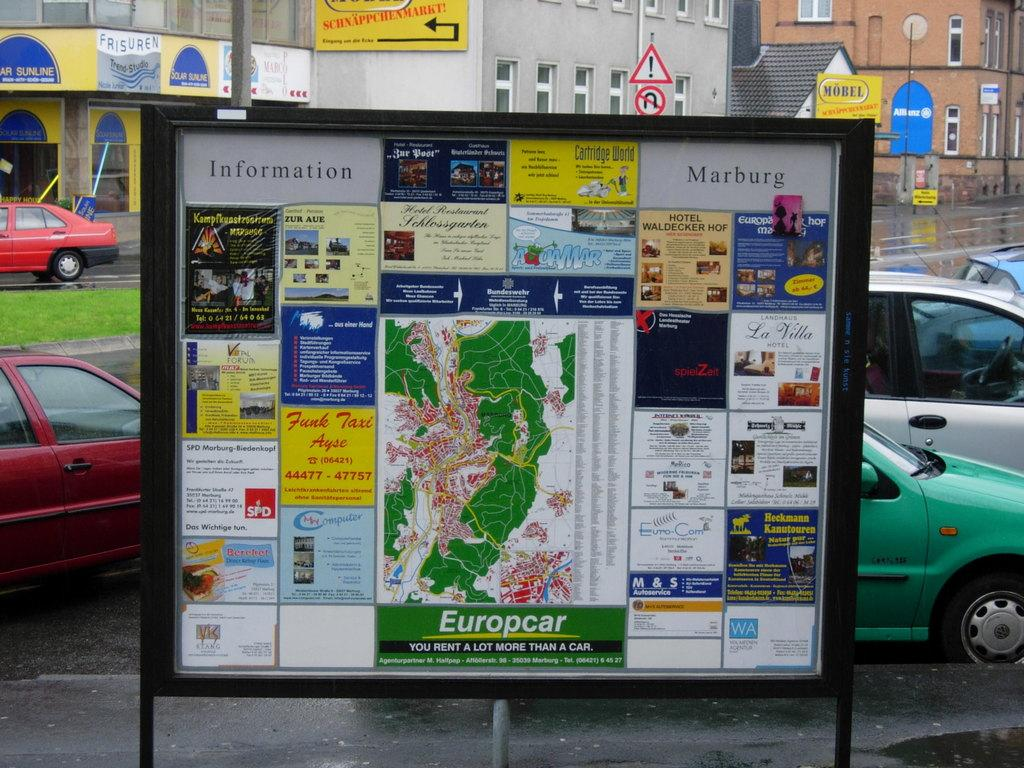<image>
Create a compact narrative representing the image presented. A sign by a parking lot says Information Marburg and has a map on it. 